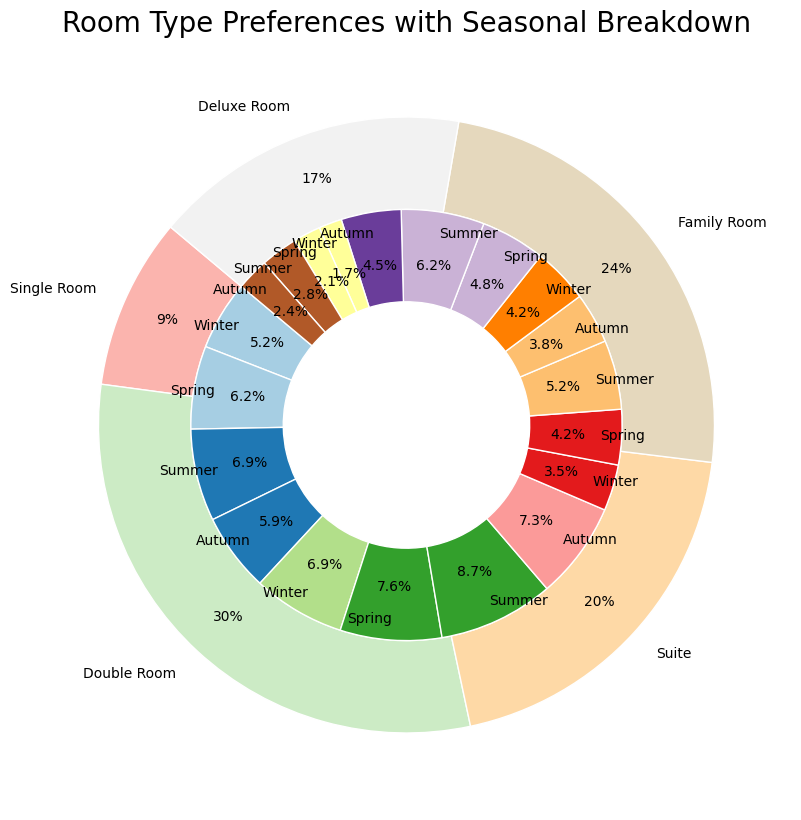What percentage of the total occupancy rate does the Single Room type account for? To find this, sum the occupancy rates for Single Room across all seasons: 0.15 (Winter) + 0.18 (Spring) + 0.20 (Summer) + 0.17 (Autumn) = 0.70, then convert to percentage: 0.70 * 100% = 70%
Answer: 70% Which room type has the highest occupancy rate in Winter? By looking at the outer sections corresponding to Winter for each room type, we can see that the Double Room has the highest occupancy rate at 20% for Winter
Answer: Double Room Is the occupancy rate for Summer higher in Family Rooms or Deluxe Rooms? Comparing the inner pie slices for Summer in Family Rooms (0.18 or 18%) and Deluxe Rooms (0.08 or 8%), we see that Family Rooms have a higher rate
Answer: Family Room Which season has the least occupancy rate for Suites? By examining the inner pie slices corresponding to Suites, the Winter season shows the lowest occupancy rate at 10% compared to 12% (Spring), 15% (Summer), and 11% (Autumn)
Answer: Winter What is the difference in occupancy rate between Deluxe Rooms in Winter and Summer? The occupancy rate for Deluxe Rooms in Winter is 0.05 (or 5%) and in Summer is 0.08 (or 8%). The difference is 0.08 - 0.05 = 0.03 or 3%
Answer: 3% What is the occupancy rate of Single Rooms during Autumn as a percentage of the total occupancy rate for Single Rooms? The total occupancy rate for Single Rooms is 70%. During Autumn, the rate is 17%. So, (0.17 / 0.70) * 100% = 24.3%
Answer: 24.3% Which room type exhibits the most variance in occupancy rates across different seasons? Examining the occupancy rates for each room type across all seasons: Single Room (15%, 18%, 20%, 17%), Double Room (20%, 22%, 25%, 21%), Suite (10%, 12%, 15%, 11%), Family Room (12%, 14%, 18%, 13%), Deluxe Room (5%, 6%, 8%, 7%). The Double Room varies the most, between 20% and 25%, showing the largest spread
Answer: Double Room Which season has the highest overall occupancy rate? Summing the occupancy rates for all room types per season: Winter (61%), Spring (72%), Summer (86%), Autumn (69%). Summer has the highest at 86%
Answer: Summer In Family Rooms, what is the total occupancy rate for the first half of the year (Winter and Spring)? Summing Winter and Spring occupancy rates for Family Rooms: 0.12 (Winter) + 0.14 (Spring) = 0.26 or 26%
Answer: 26% Which season sees the lowest occupancy rate for Deluxe Rooms and how much is it? By looking at Deluxe Room's occupancy rates across all seasons, the lowest rate is in Winter at 5%
Answer: Winter, 5% 